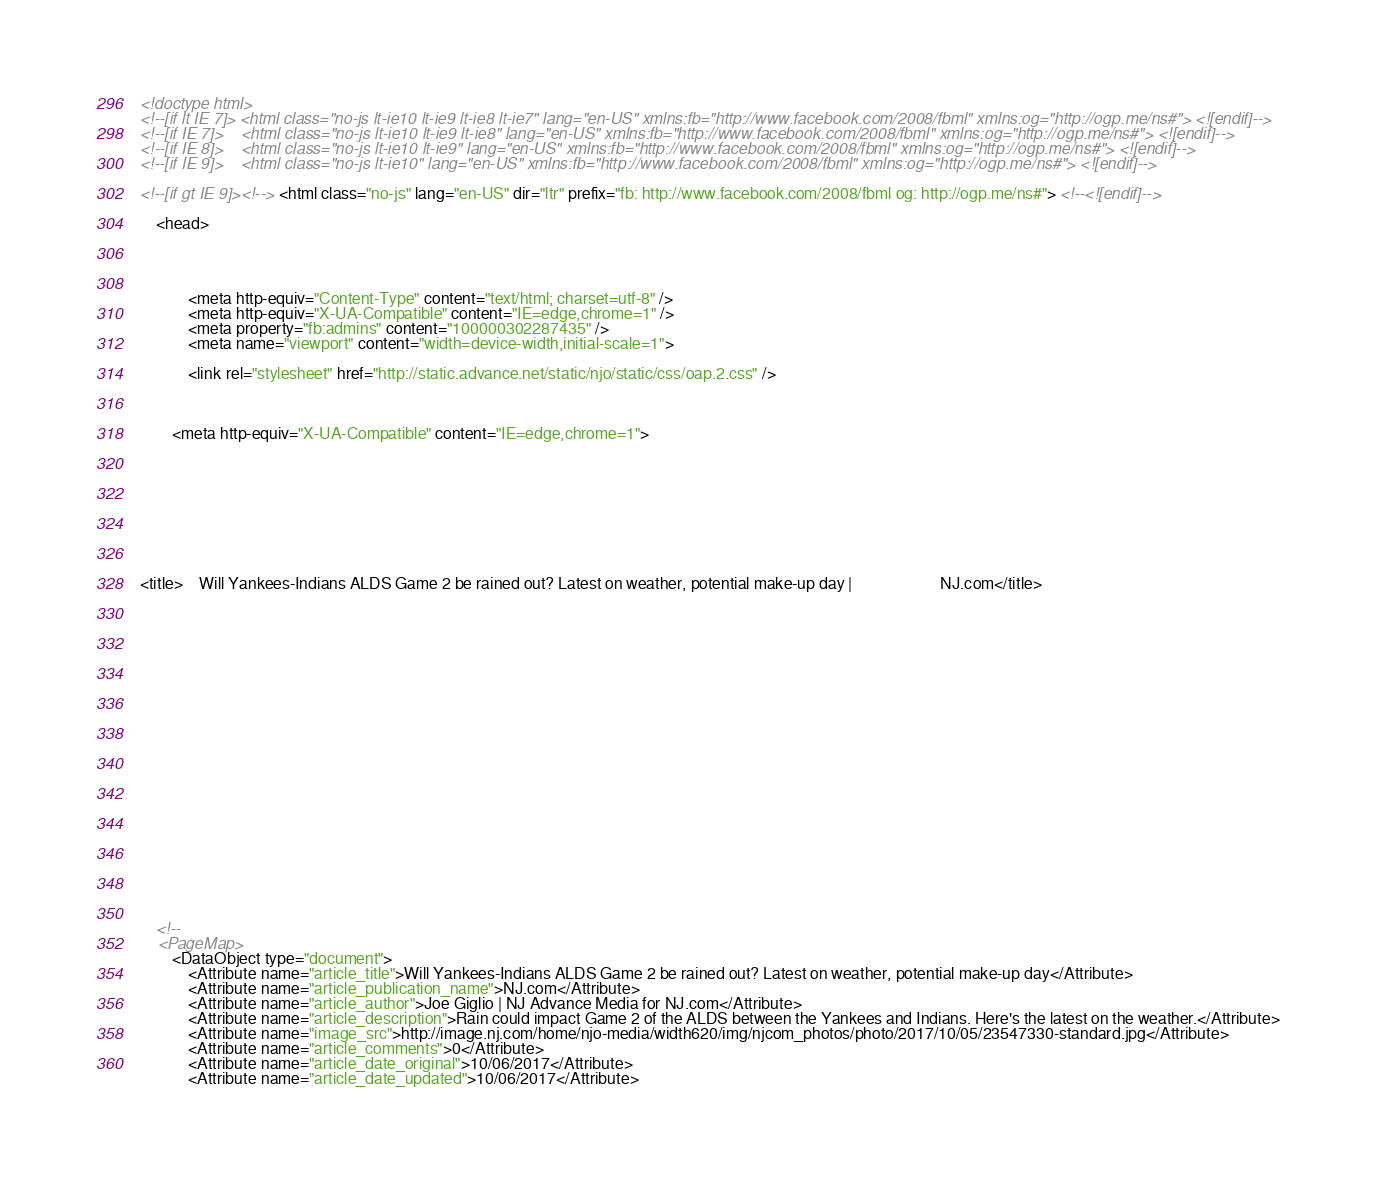Convert code to text. <code><loc_0><loc_0><loc_500><loc_500><_HTML_>
<!doctype html>
<!--[if lt IE 7]> <html class="no-js lt-ie10 lt-ie9 lt-ie8 lt-ie7" lang="en-US" xmlns:fb="http://www.facebook.com/2008/fbml" xmlns:og="http://ogp.me/ns#"> <![endif]-->
<!--[if IE 7]>    <html class="no-js lt-ie10 lt-ie9 lt-ie8" lang="en-US" xmlns:fb="http://www.facebook.com/2008/fbml" xmlns:og="http://ogp.me/ns#"> <![endif]-->
<!--[if IE 8]>    <html class="no-js lt-ie10 lt-ie9" lang="en-US" xmlns:fb="http://www.facebook.com/2008/fbml" xmlns:og="http://ogp.me/ns#"> <![endif]-->
<!--[if IE 9]>    <html class="no-js lt-ie10" lang="en-US" xmlns:fb="http://www.facebook.com/2008/fbml" xmlns:og="http://ogp.me/ns#"> <![endif]-->

<!--[if gt IE 9]><!--> <html class="no-js" lang="en-US" dir="ltr" prefix="fb: http://www.facebook.com/2008/fbml og: http://ogp.me/ns#"> <!--<![endif]-->

	<head>




			<meta http-equiv="Content-Type" content="text/html; charset=utf-8" />
			<meta http-equiv="X-UA-Compatible" content="IE=edge,chrome=1" />
			<meta property="fb:admins" content="100000302287435" />
			<meta name="viewport" content="width=device-width,initial-scale=1">

			<link rel="stylesheet" href="http://static.advance.net/static/njo/static/css/oap.2.css" />



		<meta http-equiv="X-UA-Compatible" content="IE=edge,chrome=1">









<title>	Will Yankees-Indians ALDS Game 2 be rained out? Latest on weather, potential make-up day | 						NJ.com</title>






















	<!--
	<PageMap>
		<DataObject type="document">
			<Attribute name="article_title">Will Yankees-Indians ALDS Game 2 be rained out? Latest on weather, potential make-up day</Attribute>
			<Attribute name="article_publication_name">NJ.com</Attribute>
			<Attribute name="article_author">Joe Giglio | NJ Advance Media for NJ.com</Attribute>
			<Attribute name="article_description">Rain could impact Game 2 of the ALDS between the Yankees and Indians. Here's the latest on the weather.</Attribute>
			<Attribute name="image_src">http://image.nj.com/home/njo-media/width620/img/njcom_photos/photo/2017/10/05/23547330-standard.jpg</Attribute>
			<Attribute name="article_comments">0</Attribute>
			<Attribute name="article_date_original">10/06/2017</Attribute>
			<Attribute name="article_date_updated">10/06/2017</Attribute></code> 